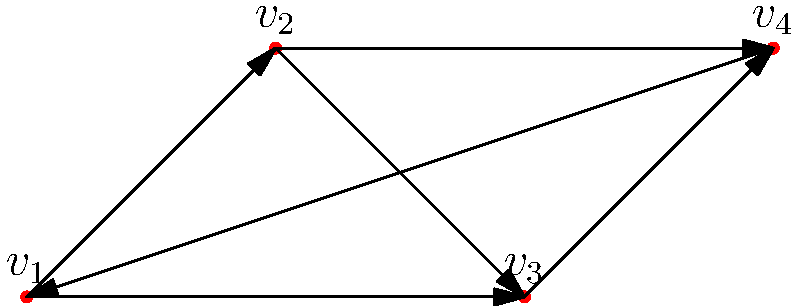In the context of group theory, consider the directed graph shown above representing a group action on a set of four elements. If this graph represents the action of a cyclic group $G$ on the set $S = \{v_1, v_2, v_3, v_4\}$, what is the order of the group $G$? Explain your reasoning, drawing parallels to how this concept might be applied in film narrative structures. To determine the order of the cyclic group $G$ acting on the set $S$, we need to analyze the graph structure:

1. Observe that each vertex has exactly one outgoing edge to each other vertex, including itself.

2. This suggests that the group action is transitive (any element can be mapped to any other element) and faithful (each group element corresponds to a unique permutation of the set).

3. The number of possible permutations of a set with 4 elements is 4! = 24. However, not all of these permutations are represented in the graph.

4. Notice that the graph shows a cyclic structure: following the outer edges, we get the cycle $(v_1, v_2, v_3, v_4)$.

5. This cycle corresponds to a generator of the group, which we can call $g$. The powers of $g$ give us:
   $g^1 = (v_1, v_2, v_3, v_4)$
   $g^2 = (v_1, v_3)(v_2, v_4)$
   $g^3 = (v_1, v_4, v_3, v_2)$
   $g^4 = (v_1)(v_2)(v_3)(v_4)$ (identity)

6. Therefore, the group $G$ has 4 elements: $\{e, g, g^2, g^3\}$, where $e$ is the identity element.

In film narrative terms, this cyclic structure could be likened to a story that progresses through four distinct emotional states or plot points, always in the same order, eventually returning to the beginning. This creates a sense of completeness and closure, much like how a cyclic group action returns to the identity after a finite number of applications.
Answer: 4 